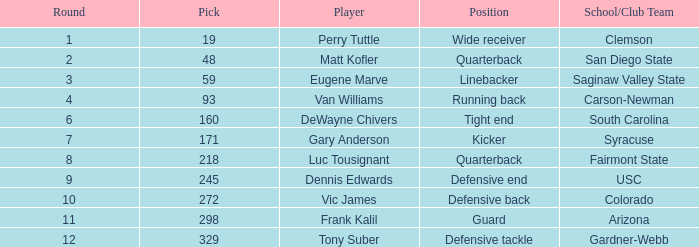Which Round has a School/Club Team of arizona, and a Pick smaller than 298? None. 